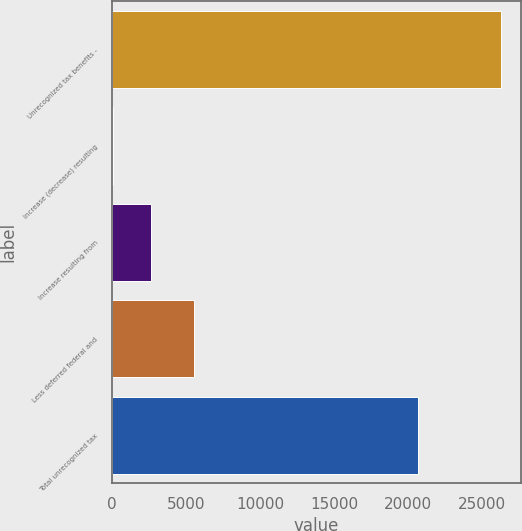<chart> <loc_0><loc_0><loc_500><loc_500><bar_chart><fcel>Unrecognized tax benefits -<fcel>Increase (decrease) resulting<fcel>Increase resulting from<fcel>Less deferred federal and<fcel>Total unrecognized tax<nl><fcel>26337.1<fcel>22<fcel>2640.1<fcel>5503<fcel>20700<nl></chart> 